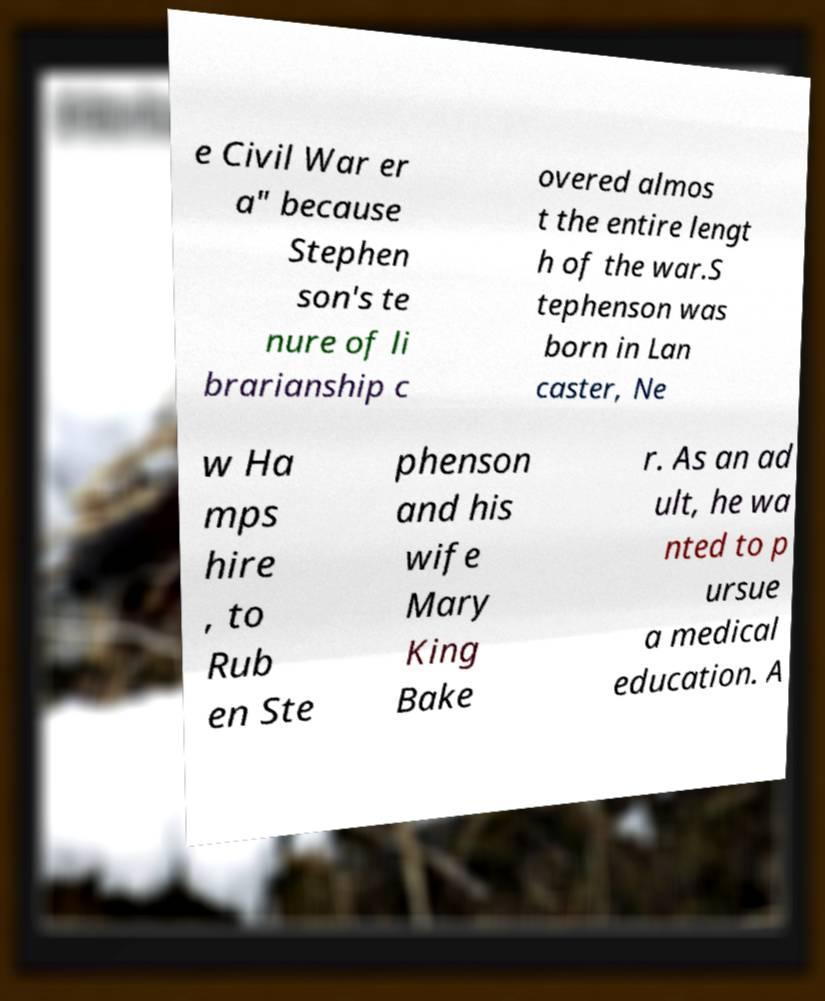Can you read and provide the text displayed in the image?This photo seems to have some interesting text. Can you extract and type it out for me? e Civil War er a" because Stephen son's te nure of li brarianship c overed almos t the entire lengt h of the war.S tephenson was born in Lan caster, Ne w Ha mps hire , to Rub en Ste phenson and his wife Mary King Bake r. As an ad ult, he wa nted to p ursue a medical education. A 